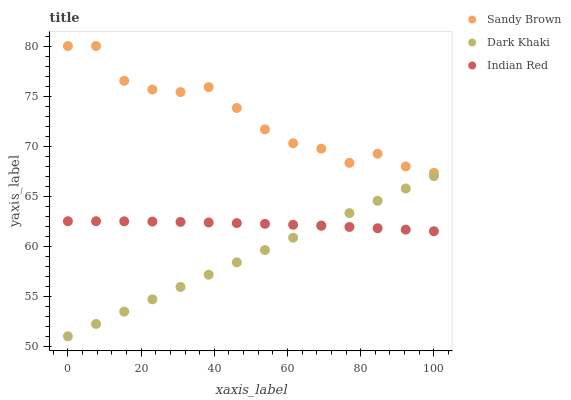Does Dark Khaki have the minimum area under the curve?
Answer yes or no. Yes. Does Sandy Brown have the maximum area under the curve?
Answer yes or no. Yes. Does Indian Red have the minimum area under the curve?
Answer yes or no. No. Does Indian Red have the maximum area under the curve?
Answer yes or no. No. Is Dark Khaki the smoothest?
Answer yes or no. Yes. Is Sandy Brown the roughest?
Answer yes or no. Yes. Is Indian Red the smoothest?
Answer yes or no. No. Is Indian Red the roughest?
Answer yes or no. No. Does Dark Khaki have the lowest value?
Answer yes or no. Yes. Does Indian Red have the lowest value?
Answer yes or no. No. Does Sandy Brown have the highest value?
Answer yes or no. Yes. Does Indian Red have the highest value?
Answer yes or no. No. Is Dark Khaki less than Sandy Brown?
Answer yes or no. Yes. Is Sandy Brown greater than Dark Khaki?
Answer yes or no. Yes. Does Dark Khaki intersect Indian Red?
Answer yes or no. Yes. Is Dark Khaki less than Indian Red?
Answer yes or no. No. Is Dark Khaki greater than Indian Red?
Answer yes or no. No. Does Dark Khaki intersect Sandy Brown?
Answer yes or no. No. 